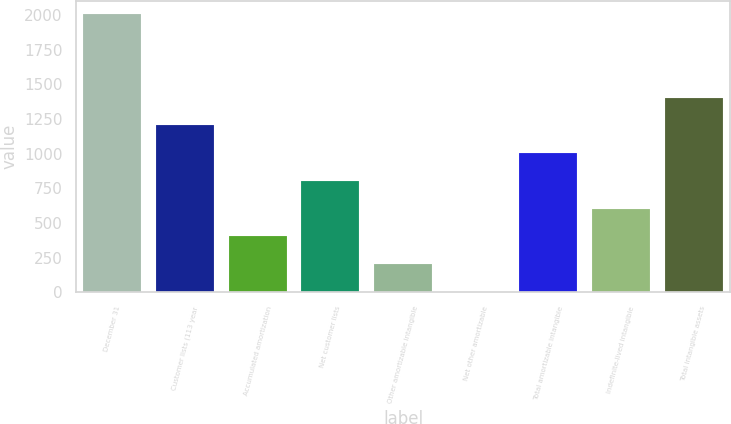<chart> <loc_0><loc_0><loc_500><loc_500><bar_chart><fcel>December 31<fcel>Customer lists (113 year<fcel>Accumulated amortization<fcel>Net customer lists<fcel>Other amortizable intangible<fcel>Net other amortizable<fcel>Total amortizable intangible<fcel>Indefinite-lived intangible<fcel>Total intangible assets<nl><fcel>2004<fcel>1203.64<fcel>403.28<fcel>803.46<fcel>203.19<fcel>3.1<fcel>1003.55<fcel>603.37<fcel>1403.73<nl></chart> 